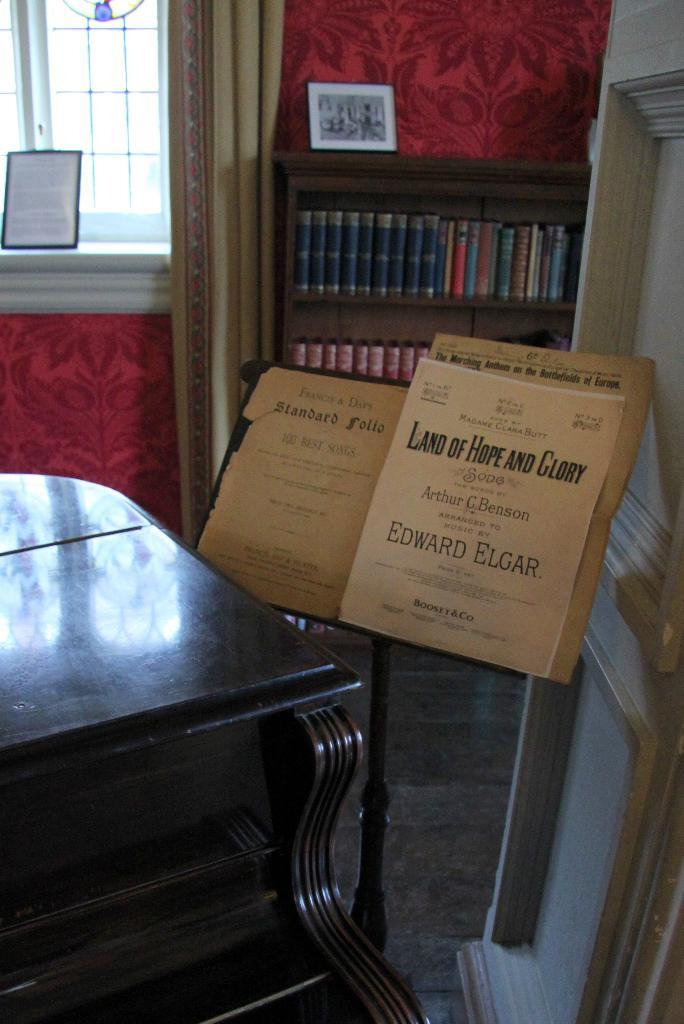Provide a one-sentence caption for the provided image. Music on a stand with Land of Hope and Glory written on it. 